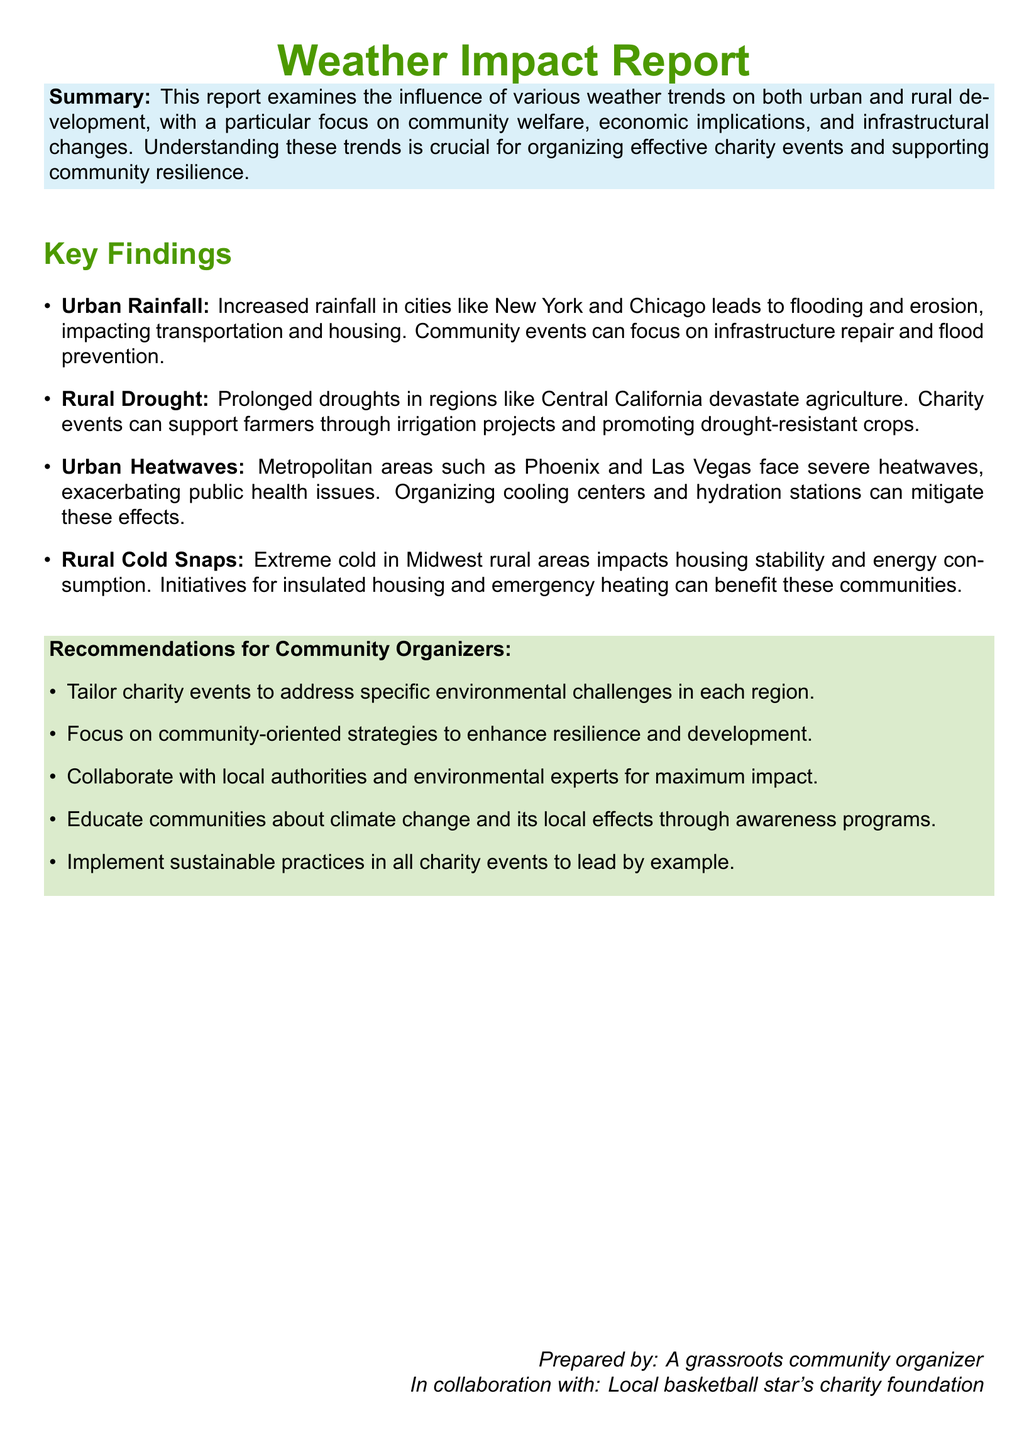What is the focus of this report? The report examines the influence of various weather trends on community welfare, economic implications, and infrastructural changes.
Answer: community welfare Which cities are mentioned in relation to increased rainfall? The report mentions cities like New York and Chicago in the context of increased rainfall leading to flooding and erosion.
Answer: New York and Chicago What impact does prolonged drought have on agriculture? The report states that prolonged droughts devastate agriculture in regions like Central California.
Answer: devastates agriculture What urban area is identified as facing severe heatwaves? The metropolitan area mentioned in relation to severe heatwaves is Phoenix and Las Vegas.
Answer: Phoenix and Las Vegas What type of initiatives are recommended for extreme cold in rural areas? The report suggests initiatives for insulated housing and emergency heating to benefit communities affected by extreme cold.
Answer: insulated housing and emergency heating What is one recommendation for community organizers? One recommendation is to tailor charity events to address specific environmental challenges in each region.
Answer: tailor charity events What does the report suggest as a way to educate communities? The report recommends educating communities about climate change and its local effects through awareness programs.
Answer: awareness programs Who collaborated with the grassroots community organizer to prepare this report? The local basketball star's charity foundation is identified as a collaborator in preparing this report.
Answer: Local basketball star's charity foundation 